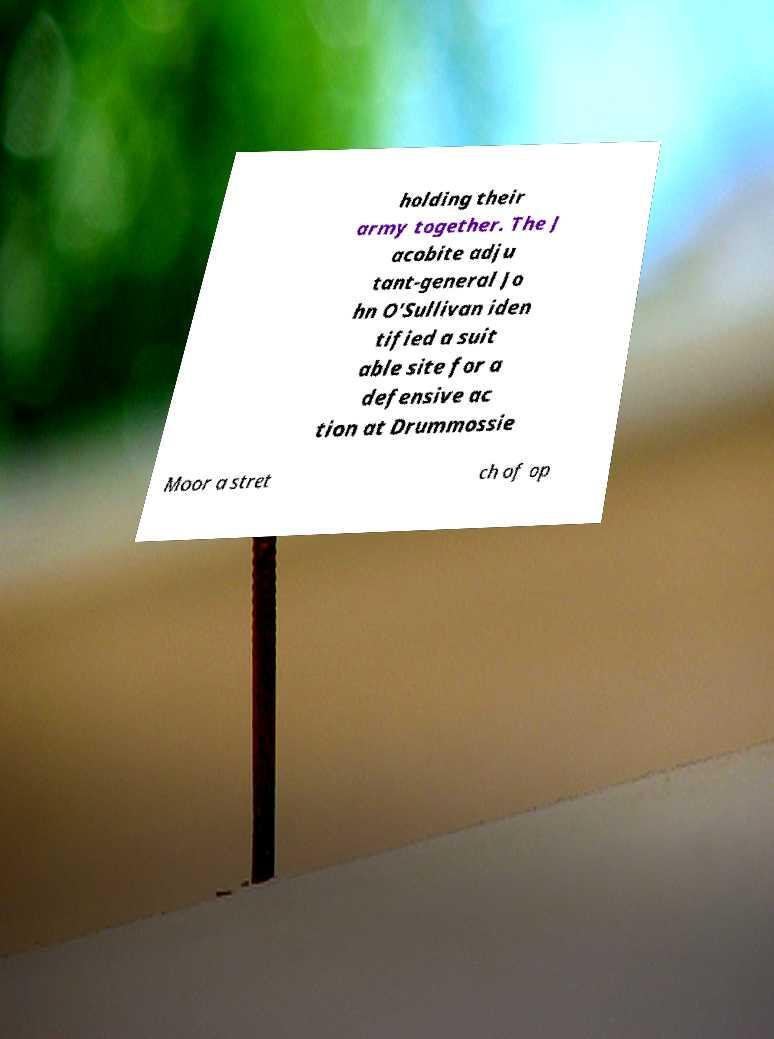Can you accurately transcribe the text from the provided image for me? holding their army together. The J acobite adju tant-general Jo hn O'Sullivan iden tified a suit able site for a defensive ac tion at Drummossie Moor a stret ch of op 